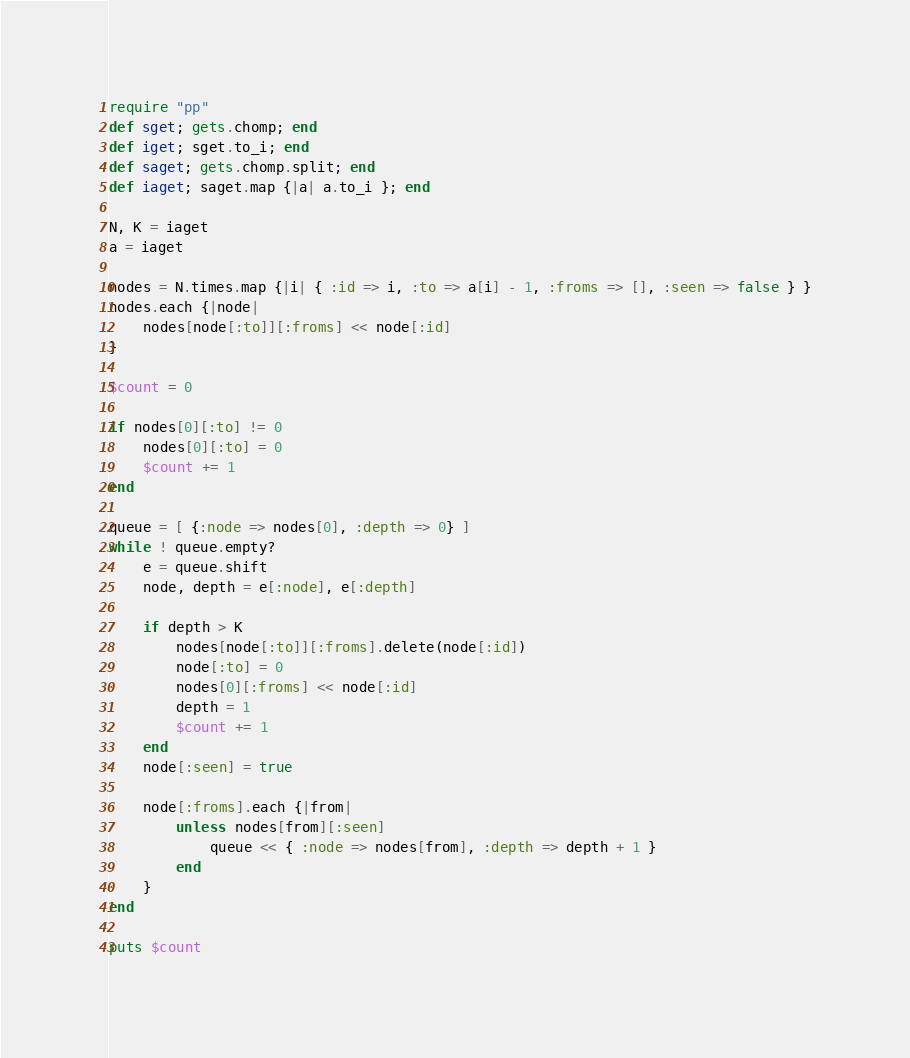Convert code to text. <code><loc_0><loc_0><loc_500><loc_500><_Ruby_>require "pp"
def sget; gets.chomp; end
def iget; sget.to_i; end
def saget; gets.chomp.split; end
def iaget; saget.map {|a| a.to_i }; end

N, K = iaget
a = iaget

nodes = N.times.map {|i| { :id => i, :to => a[i] - 1, :froms => [], :seen => false } }
nodes.each {|node|
    nodes[node[:to]][:froms] << node[:id]
}

$count = 0

if nodes[0][:to] != 0
    nodes[0][:to] = 0
    $count += 1
end

queue = [ {:node => nodes[0], :depth => 0} ]
while ! queue.empty?
    e = queue.shift
    node, depth = e[:node], e[:depth]

    if depth > K
        nodes[node[:to]][:froms].delete(node[:id])
        node[:to] = 0
        nodes[0][:froms] << node[:id]
        depth = 1
        $count += 1
    end
    node[:seen] = true

    node[:froms].each {|from|
        unless nodes[from][:seen]
            queue << { :node => nodes[from], :depth => depth + 1 }
        end
    }
end

puts $count
</code> 